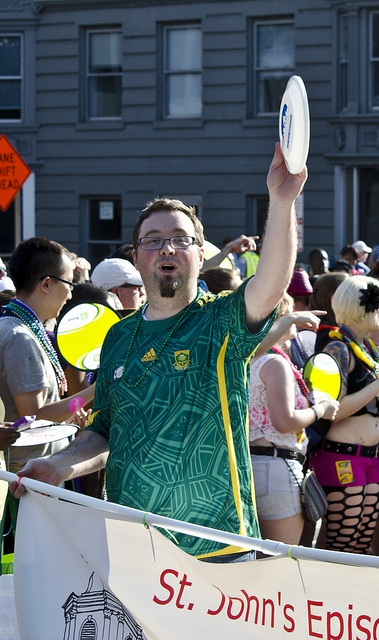Describe the objects in this image and their specific colors. I can see people in darkblue, teal, black, gray, and darkgray tones, people in darkblue, black, gray, and darkgray tones, people in darkblue, darkgray, gray, and black tones, people in darkblue, black, gray, and white tones, and frisbee in darkblue, yellow, white, black, and khaki tones in this image. 